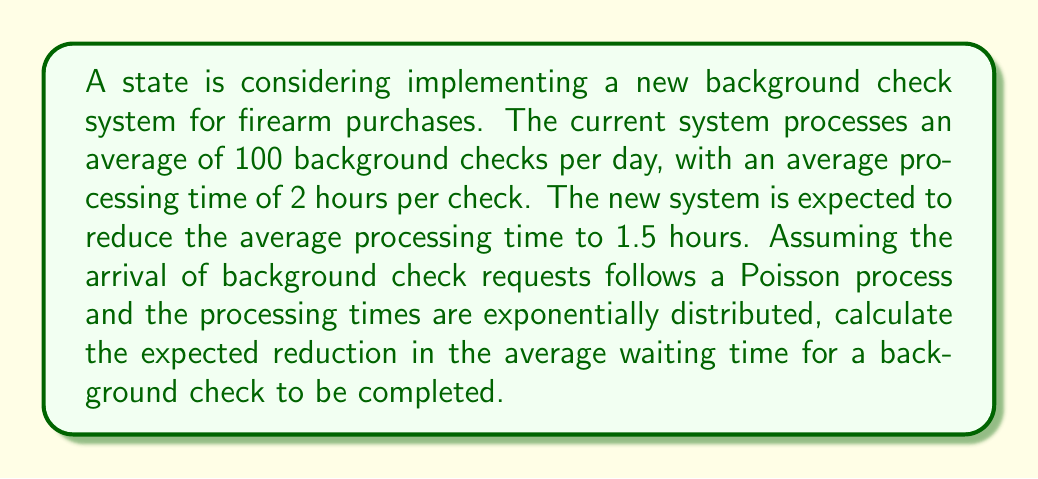Provide a solution to this math problem. Let's approach this problem using M/M/1 queuing theory:

1. Current system:
   - Arrival rate: $\lambda = 100/24 = 4.17$ checks/hour
   - Service rate: $\mu = 1/2 = 0.5$ checks/hour

2. New system:
   - Arrival rate: $\lambda = 100/24 = 4.17$ checks/hour (unchanged)
   - Service rate: $\mu = 1/1.5 = 0.67$ checks/hour

3. For an M/M/1 queue, the average time in the system (W) is given by:

   $$W = \frac{1}{\mu - \lambda}$$

4. Current system's average waiting time:
   $$W_1 = \frac{1}{0.5 - 4.17} = -0.27 \text{ hours}$$
   
   This negative result indicates that the current system is unstable and cannot handle the incoming requests.

5. New system's average waiting time:
   $$W_2 = \frac{1}{0.67 - 4.17} = -0.29 \text{ hours}$$
   
   The new system is also unstable, but slightly less so.

6. The reduction in average waiting time:
   $$\Delta W = W_1 - W_2 = -0.27 - (-0.29) = 0.02 \text{ hours} = 1.2 \text{ minutes}$$

While there is a slight improvement, both systems are overwhelmed and cannot handle the current load. To create a stable system, either the arrival rate needs to be reduced or the service rate needs to be increased significantly.
Answer: 1.2 minutes 